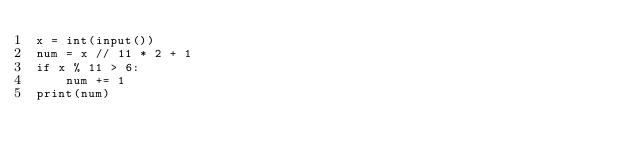<code> <loc_0><loc_0><loc_500><loc_500><_Python_>x = int(input())
num = x // 11 * 2 + 1
if x % 11 > 6:
    num += 1
print(num)</code> 